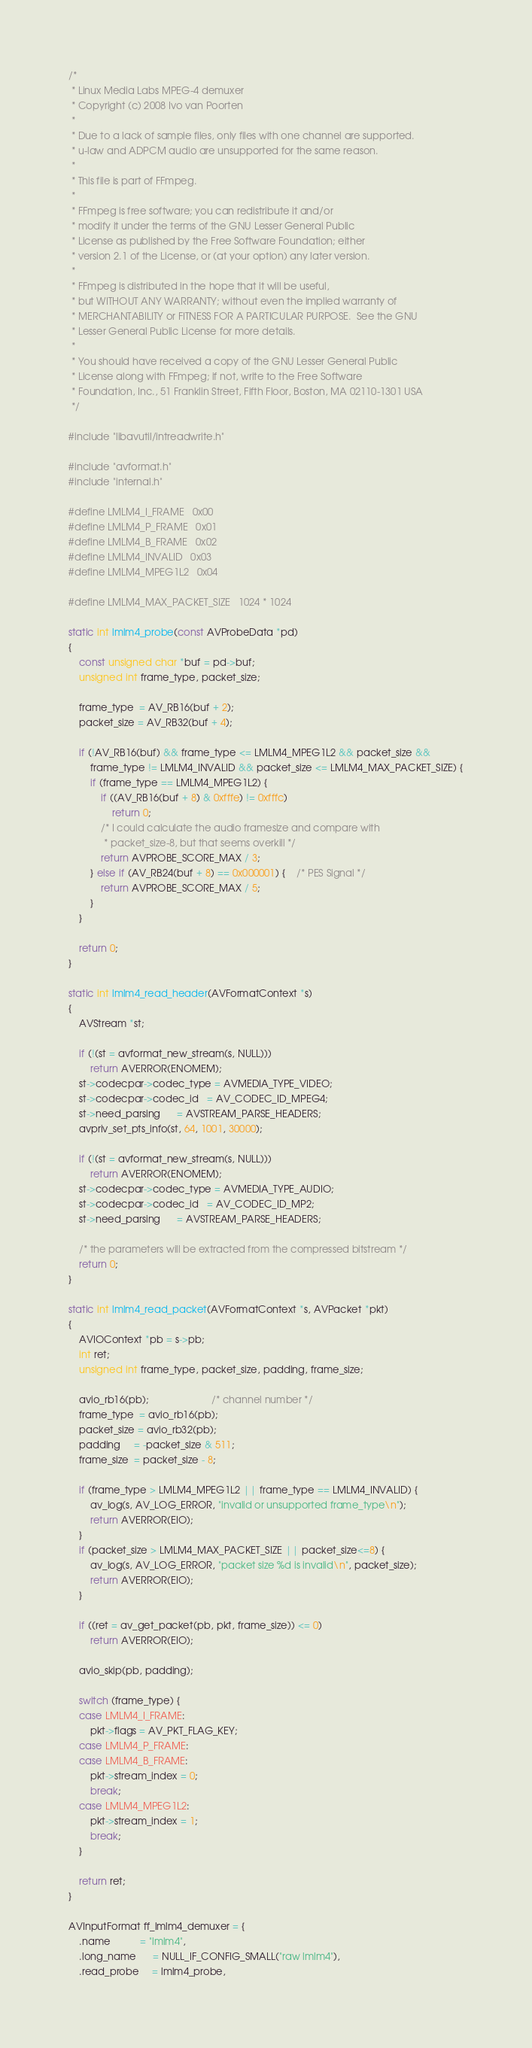<code> <loc_0><loc_0><loc_500><loc_500><_C_>/*
 * Linux Media Labs MPEG-4 demuxer
 * Copyright (c) 2008 Ivo van Poorten
 *
 * Due to a lack of sample files, only files with one channel are supported.
 * u-law and ADPCM audio are unsupported for the same reason.
 *
 * This file is part of FFmpeg.
 *
 * FFmpeg is free software; you can redistribute it and/or
 * modify it under the terms of the GNU Lesser General Public
 * License as published by the Free Software Foundation; either
 * version 2.1 of the License, or (at your option) any later version.
 *
 * FFmpeg is distributed in the hope that it will be useful,
 * but WITHOUT ANY WARRANTY; without even the implied warranty of
 * MERCHANTABILITY or FITNESS FOR A PARTICULAR PURPOSE.  See the GNU
 * Lesser General Public License for more details.
 *
 * You should have received a copy of the GNU Lesser General Public
 * License along with FFmpeg; if not, write to the Free Software
 * Foundation, Inc., 51 Franklin Street, Fifth Floor, Boston, MA 02110-1301 USA
 */

#include "libavutil/intreadwrite.h"

#include "avformat.h"
#include "internal.h"

#define LMLM4_I_FRAME   0x00
#define LMLM4_P_FRAME   0x01
#define LMLM4_B_FRAME   0x02
#define LMLM4_INVALID   0x03
#define LMLM4_MPEG1L2   0x04

#define LMLM4_MAX_PACKET_SIZE   1024 * 1024

static int lmlm4_probe(const AVProbeData *pd)
{
    const unsigned char *buf = pd->buf;
    unsigned int frame_type, packet_size;

    frame_type  = AV_RB16(buf + 2);
    packet_size = AV_RB32(buf + 4);

    if (!AV_RB16(buf) && frame_type <= LMLM4_MPEG1L2 && packet_size &&
        frame_type != LMLM4_INVALID && packet_size <= LMLM4_MAX_PACKET_SIZE) {
        if (frame_type == LMLM4_MPEG1L2) {
            if ((AV_RB16(buf + 8) & 0xfffe) != 0xfffc)
                return 0;
            /* I could calculate the audio framesize and compare with
             * packet_size-8, but that seems overkill */
            return AVPROBE_SCORE_MAX / 3;
        } else if (AV_RB24(buf + 8) == 0x000001) {    /* PES Signal */
            return AVPROBE_SCORE_MAX / 5;
        }
    }

    return 0;
}

static int lmlm4_read_header(AVFormatContext *s)
{
    AVStream *st;

    if (!(st = avformat_new_stream(s, NULL)))
        return AVERROR(ENOMEM);
    st->codecpar->codec_type = AVMEDIA_TYPE_VIDEO;
    st->codecpar->codec_id   = AV_CODEC_ID_MPEG4;
    st->need_parsing      = AVSTREAM_PARSE_HEADERS;
    avpriv_set_pts_info(st, 64, 1001, 30000);

    if (!(st = avformat_new_stream(s, NULL)))
        return AVERROR(ENOMEM);
    st->codecpar->codec_type = AVMEDIA_TYPE_AUDIO;
    st->codecpar->codec_id   = AV_CODEC_ID_MP2;
    st->need_parsing      = AVSTREAM_PARSE_HEADERS;

    /* the parameters will be extracted from the compressed bitstream */
    return 0;
}

static int lmlm4_read_packet(AVFormatContext *s, AVPacket *pkt)
{
    AVIOContext *pb = s->pb;
    int ret;
    unsigned int frame_type, packet_size, padding, frame_size;

    avio_rb16(pb);                       /* channel number */
    frame_type  = avio_rb16(pb);
    packet_size = avio_rb32(pb);
    padding     = -packet_size & 511;
    frame_size  = packet_size - 8;

    if (frame_type > LMLM4_MPEG1L2 || frame_type == LMLM4_INVALID) {
        av_log(s, AV_LOG_ERROR, "invalid or unsupported frame_type\n");
        return AVERROR(EIO);
    }
    if (packet_size > LMLM4_MAX_PACKET_SIZE || packet_size<=8) {
        av_log(s, AV_LOG_ERROR, "packet size %d is invalid\n", packet_size);
        return AVERROR(EIO);
    }

    if ((ret = av_get_packet(pb, pkt, frame_size)) <= 0)
        return AVERROR(EIO);

    avio_skip(pb, padding);

    switch (frame_type) {
    case LMLM4_I_FRAME:
        pkt->flags = AV_PKT_FLAG_KEY;
    case LMLM4_P_FRAME:
    case LMLM4_B_FRAME:
        pkt->stream_index = 0;
        break;
    case LMLM4_MPEG1L2:
        pkt->stream_index = 1;
        break;
    }

    return ret;
}

AVInputFormat ff_lmlm4_demuxer = {
    .name           = "lmlm4",
    .long_name      = NULL_IF_CONFIG_SMALL("raw lmlm4"),
    .read_probe     = lmlm4_probe,</code> 